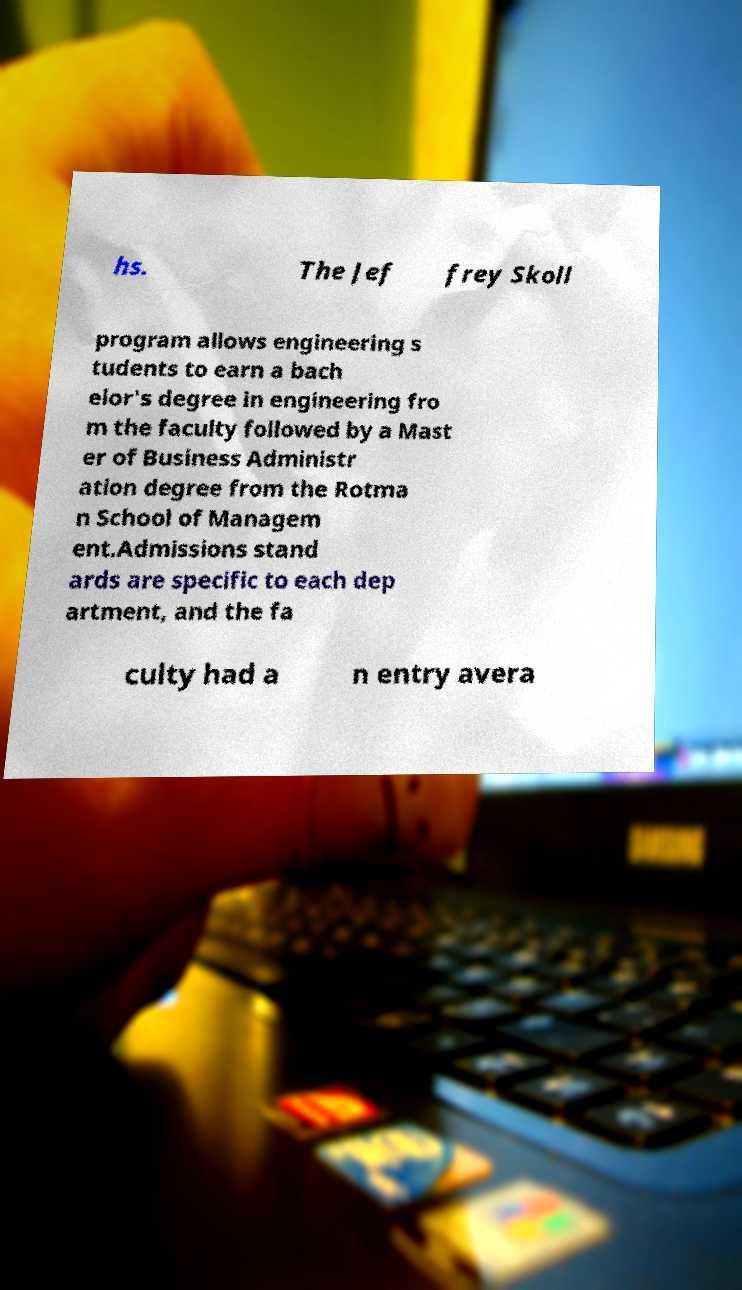For documentation purposes, I need the text within this image transcribed. Could you provide that? hs. The Jef frey Skoll program allows engineering s tudents to earn a bach elor's degree in engineering fro m the faculty followed by a Mast er of Business Administr ation degree from the Rotma n School of Managem ent.Admissions stand ards are specific to each dep artment, and the fa culty had a n entry avera 